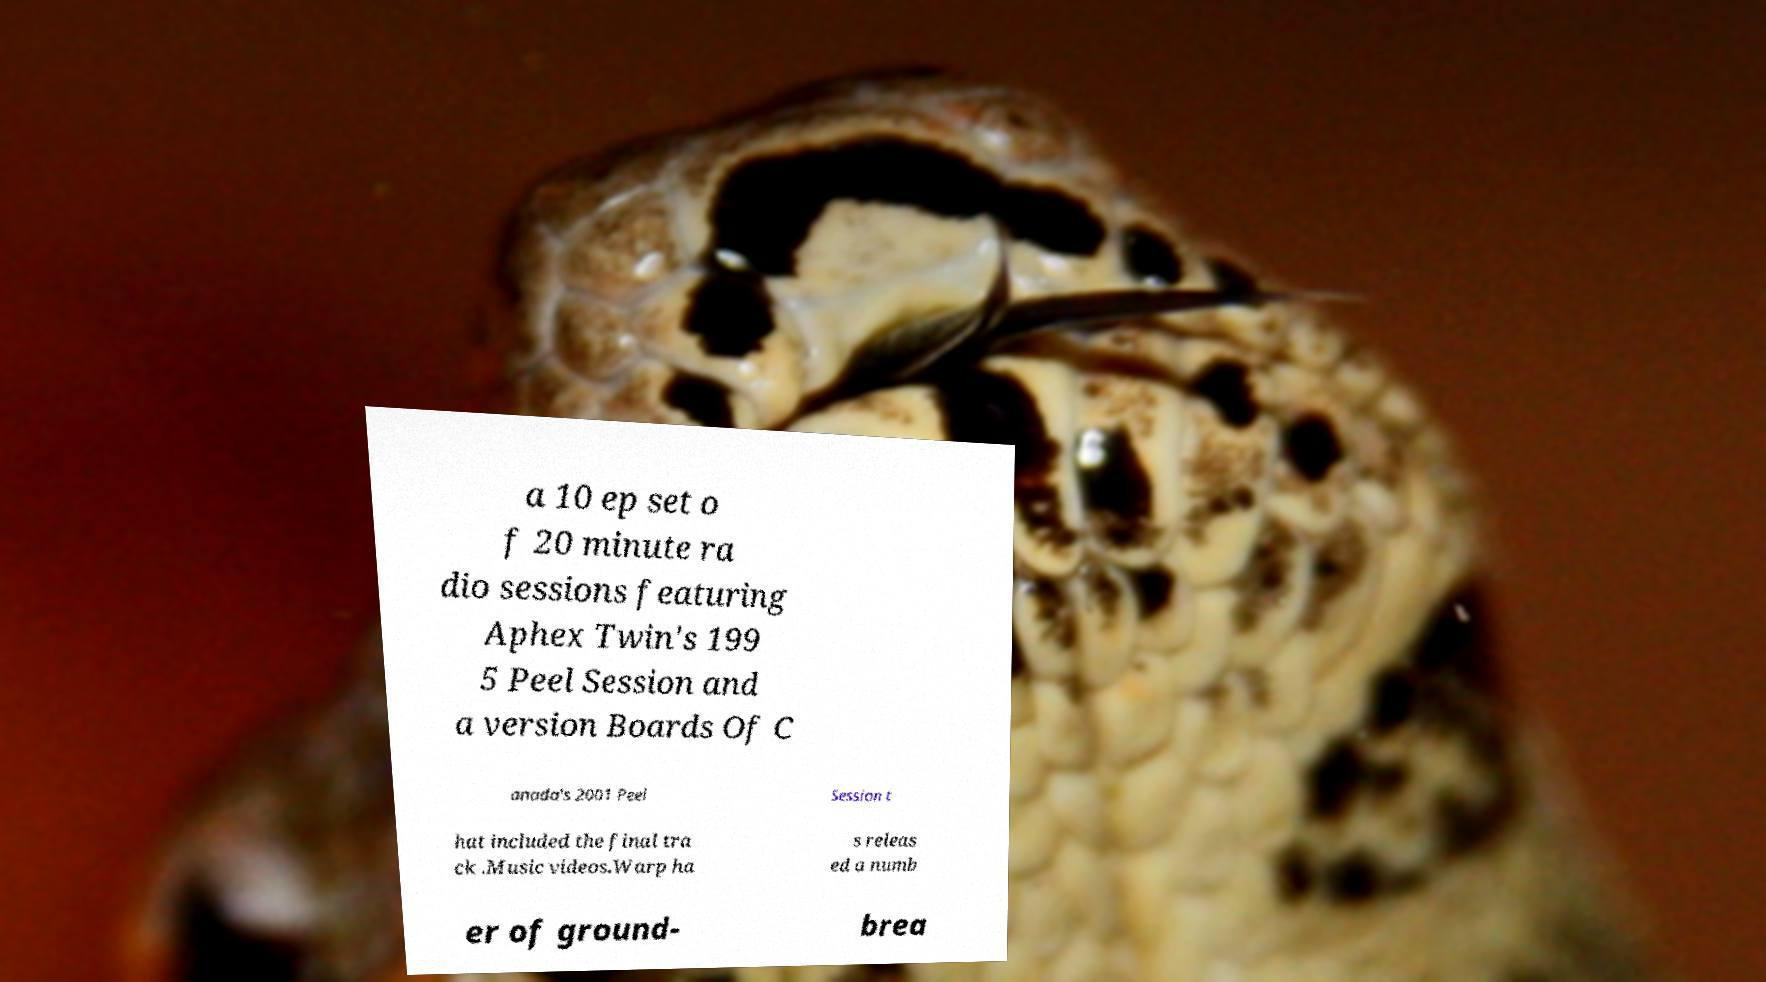What messages or text are displayed in this image? I need them in a readable, typed format. a 10 ep set o f 20 minute ra dio sessions featuring Aphex Twin's 199 5 Peel Session and a version Boards Of C anada's 2001 Peel Session t hat included the final tra ck .Music videos.Warp ha s releas ed a numb er of ground- brea 